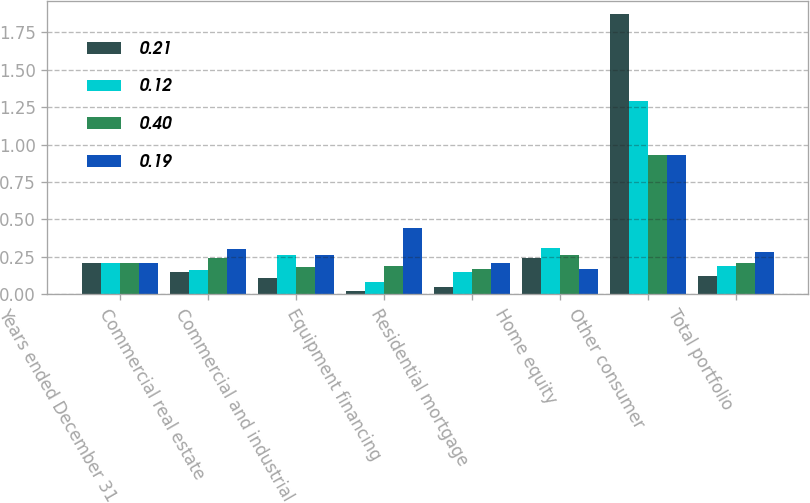Convert chart. <chart><loc_0><loc_0><loc_500><loc_500><stacked_bar_chart><ecel><fcel>Years ended December 31<fcel>Commercial real estate<fcel>Commercial and industrial<fcel>Equipment financing<fcel>Residential mortgage<fcel>Home equity<fcel>Other consumer<fcel>Total portfolio<nl><fcel>0.21<fcel>0.21<fcel>0.15<fcel>0.11<fcel>0.02<fcel>0.05<fcel>0.24<fcel>1.87<fcel>0.12<nl><fcel>0.12<fcel>0.21<fcel>0.16<fcel>0.26<fcel>0.08<fcel>0.15<fcel>0.31<fcel>1.29<fcel>0.19<nl><fcel>0.4<fcel>0.21<fcel>0.24<fcel>0.18<fcel>0.19<fcel>0.17<fcel>0.26<fcel>0.93<fcel>0.21<nl><fcel>0.19<fcel>0.21<fcel>0.3<fcel>0.26<fcel>0.44<fcel>0.21<fcel>0.17<fcel>0.93<fcel>0.28<nl></chart> 